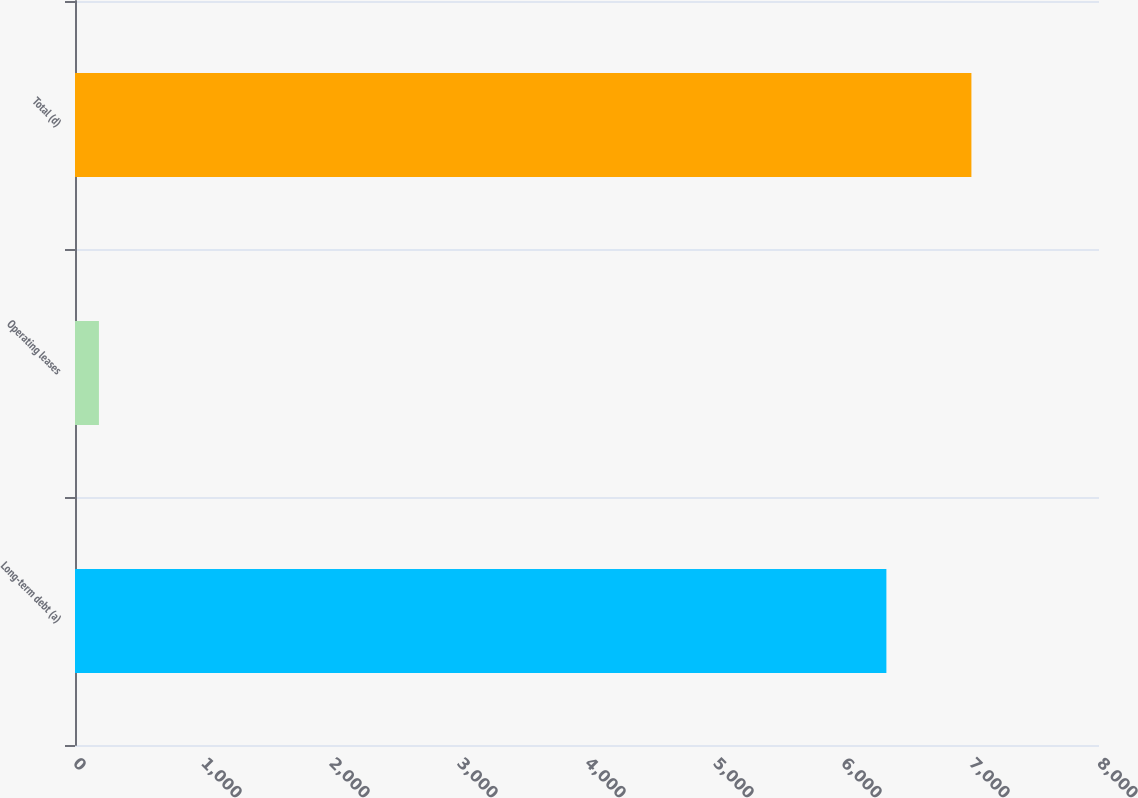Convert chart. <chart><loc_0><loc_0><loc_500><loc_500><bar_chart><fcel>Long-term debt (a)<fcel>Operating leases<fcel>Total (d)<nl><fcel>6339<fcel>187<fcel>7003.2<nl></chart> 